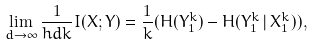Convert formula to latex. <formula><loc_0><loc_0><loc_500><loc_500>\lim _ { d \rightarrow \infty } \frac { 1 } { h d k } I ( X ; Y ) = \frac { 1 } { k } ( H ( Y _ { 1 } ^ { k } ) - H ( Y _ { 1 } ^ { k } \, | \, X _ { 1 } ^ { k } ) ) ,</formula> 